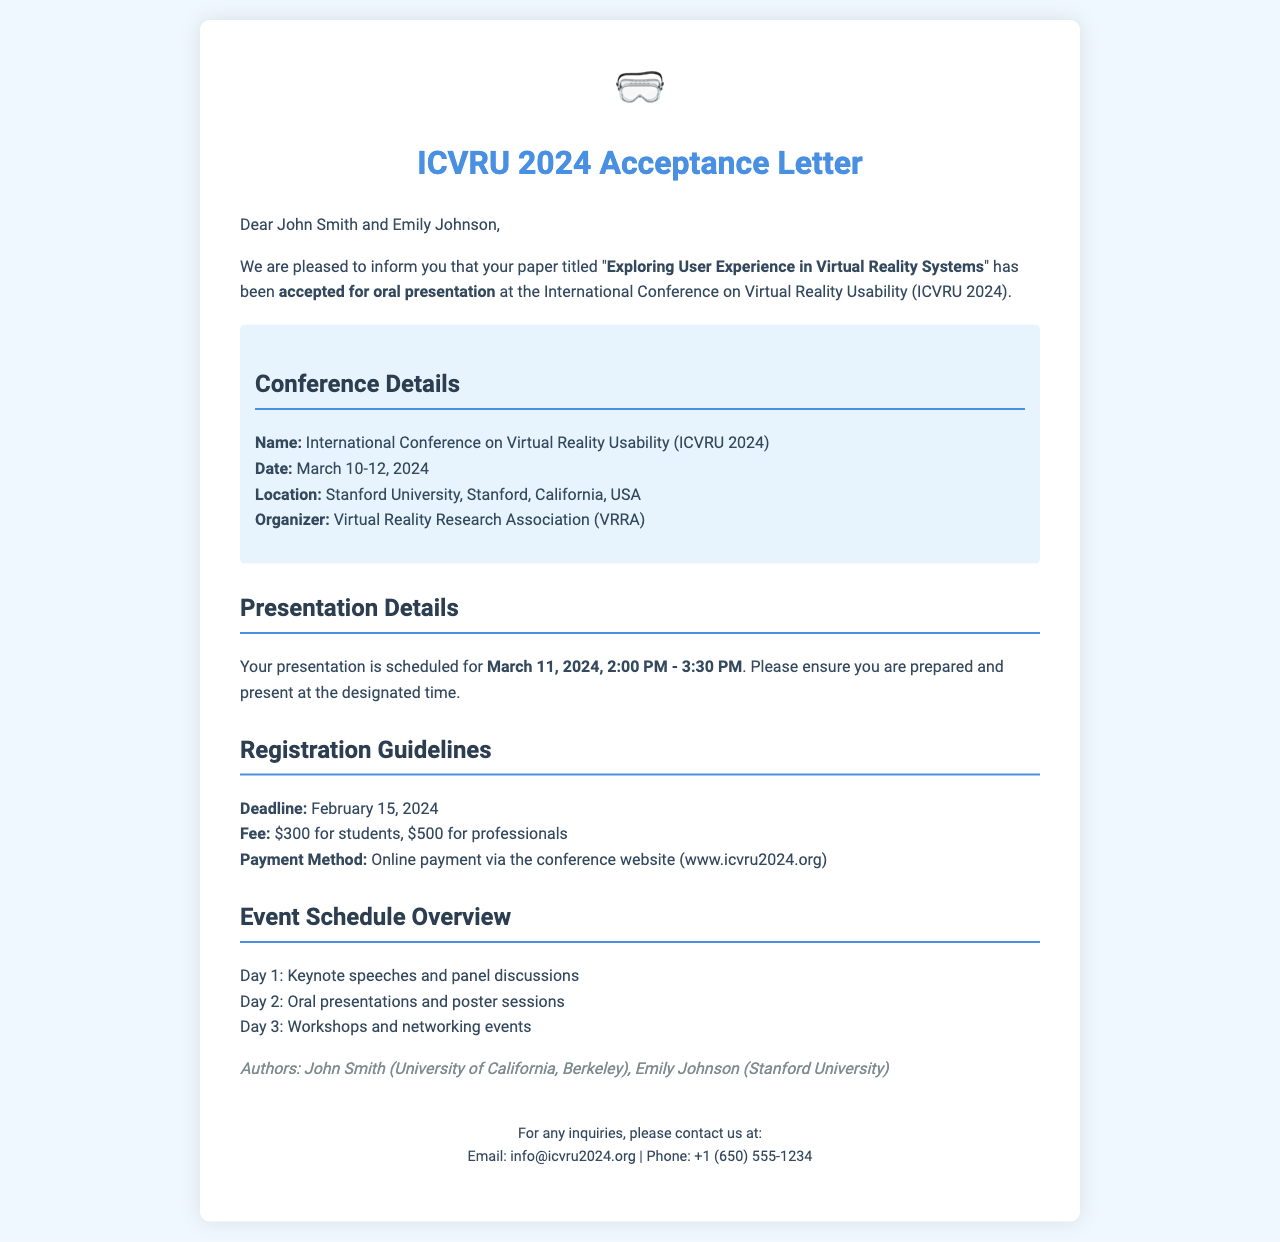What is the title of the accepted paper? The title of the accepted paper is explicitly stated in the document: "Exploring User Experience in Virtual Reality Systems."
Answer: Exploring User Experience in Virtual Reality Systems Who are the authors of the paper? The authors of the paper are listed in the document, specifying their names and affiliations.
Answer: John Smith, Emily Johnson What is the date of the conference? The document provides the specific date range for the conference.
Answer: March 10-12, 2024 Where is the conference located? The location of the conference is clearly mentioned in the document.
Answer: Stanford University, Stanford, California, USA What is the registration deadline? The registration deadline is specified in the guidelines section of the document.
Answer: February 15, 2024 How much is the registration fee for students? The document specifies the registration fee for students and professionals separately.
Answer: $300 When is the presentation scheduled? The document provides the exact date and time of the presentation.
Answer: March 11, 2024, 2:00 PM - 3:30 PM What is the organizing body of the conference? The document identifies the organizing body of the conference.
Answer: Virtual Reality Research Association (VRRA) What is the first day's schedule focused on? The document outlines the main focus of each day of the conference, starting with the first day.
Answer: Keynote speeches and panel discussions 